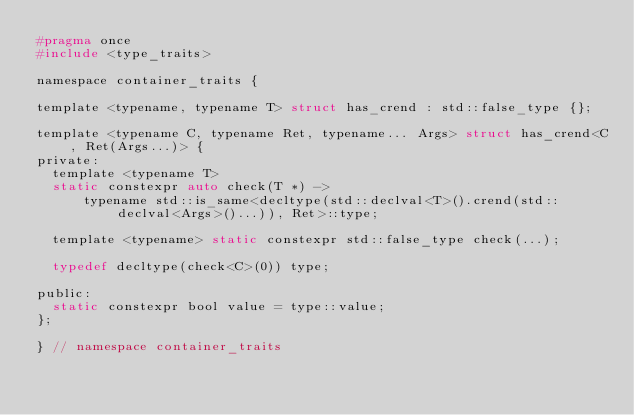<code> <loc_0><loc_0><loc_500><loc_500><_C_>#pragma once
#include <type_traits>

namespace container_traits {

template <typename, typename T> struct has_crend : std::false_type {};

template <typename C, typename Ret, typename... Args> struct has_crend<C, Ret(Args...)> {
private:
  template <typename T>
  static constexpr auto check(T *) ->
      typename std::is_same<decltype(std::declval<T>().crend(std::declval<Args>()...)), Ret>::type;

  template <typename> static constexpr std::false_type check(...);

  typedef decltype(check<C>(0)) type;

public:
  static constexpr bool value = type::value;
};

} // namespace container_traits</code> 